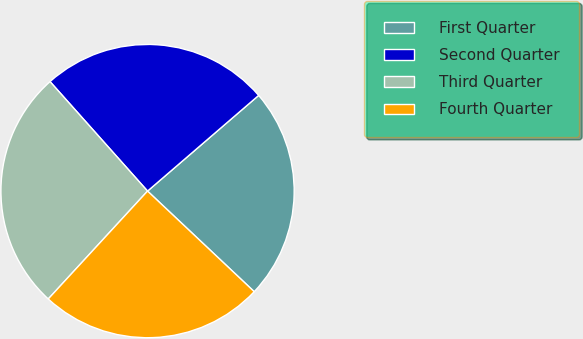Convert chart. <chart><loc_0><loc_0><loc_500><loc_500><pie_chart><fcel>First Quarter<fcel>Second Quarter<fcel>Third Quarter<fcel>Fourth Quarter<nl><fcel>23.35%<fcel>25.27%<fcel>26.58%<fcel>24.81%<nl></chart> 